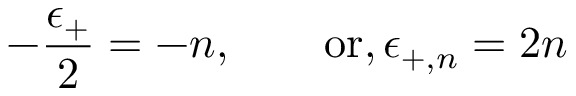Convert formula to latex. <formula><loc_0><loc_0><loc_500><loc_500>- { \frac { \epsilon _ { + } } { 2 } } = - n , \quad o r , \, \epsilon _ { + , n } = 2 n</formula> 